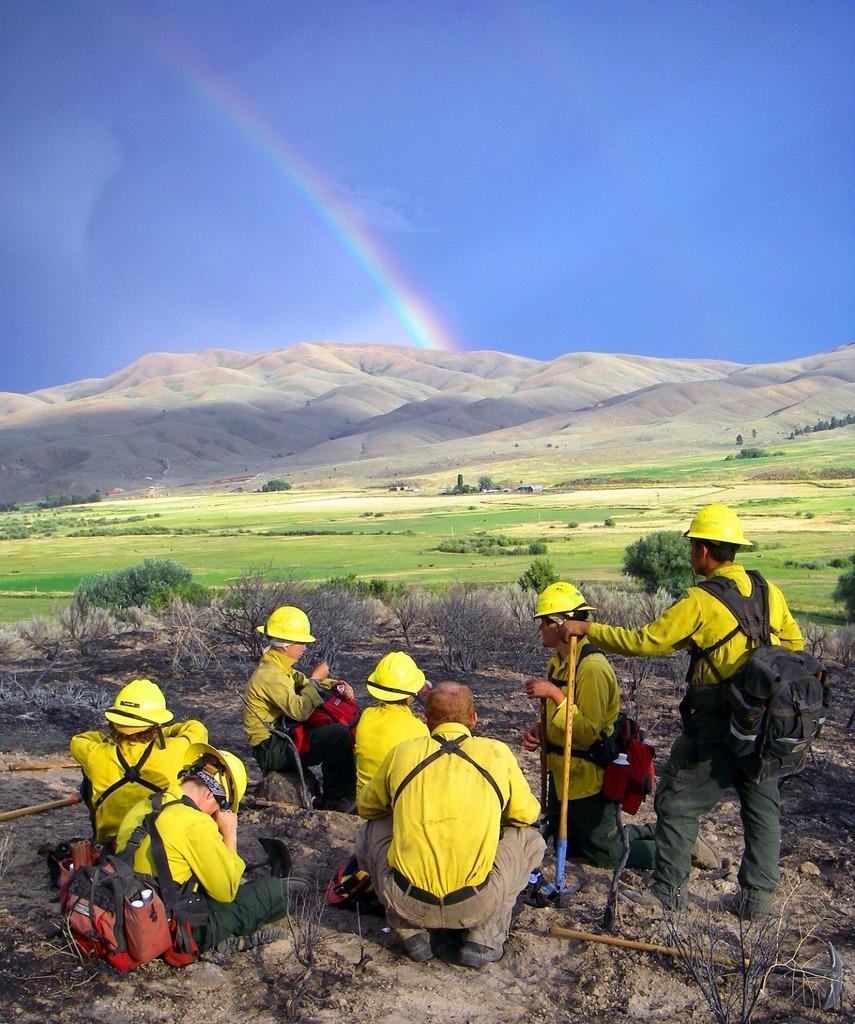Could you give a brief overview of what you see in this image? On the bottom we can see group of persons were wearing helmet, yellow shirt and trouser. On the bottom left corner we can see bags. On the right there is a man who is holding a stick. In the background we can see plants, grass, trees and mountains. Here we can see a rainbow. On the top there is a sky. 